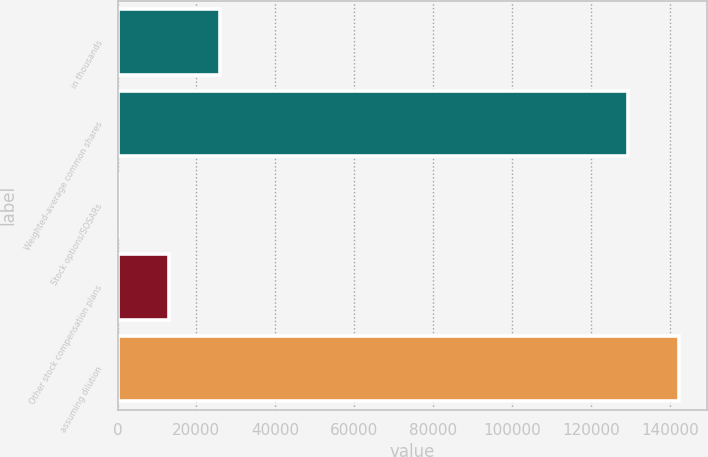Convert chart. <chart><loc_0><loc_0><loc_500><loc_500><bar_chart><fcel>in thousands<fcel>Weighted-average common shares<fcel>Stock options/SOSARs<fcel>Other stock compensation plans<fcel>assuming dilution<nl><fcel>25878.5<fcel>129381<fcel>2.89<fcel>12940.7<fcel>142319<nl></chart> 